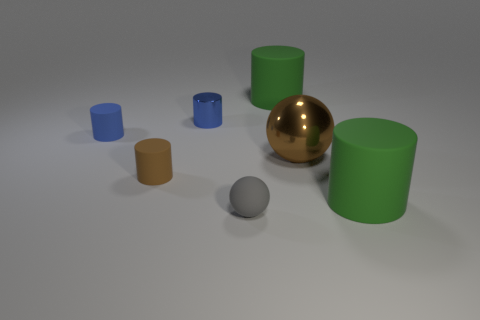Do the rubber sphere and the brown metal sphere have the same size?
Offer a terse response. No. There is a blue object that is the same material as the small gray ball; what shape is it?
Ensure brevity in your answer.  Cylinder. What number of other objects are there of the same shape as the gray matte object?
Keep it short and to the point. 1. The brown object behind the tiny rubber cylinder that is in front of the metal thing that is to the right of the matte ball is what shape?
Give a very brief answer. Sphere. What number of spheres are either tiny gray matte things or brown things?
Make the answer very short. 2. Is there a green object in front of the brown object that is on the right side of the gray matte ball?
Your answer should be compact. Yes. Are there any other things that are the same material as the large brown sphere?
Provide a short and direct response. Yes. There is a gray object; is its shape the same as the large green rubber object in front of the brown shiny sphere?
Provide a succinct answer. No. What number of other objects are there of the same size as the brown rubber cylinder?
Provide a succinct answer. 3. How many brown objects are large spheres or tiny shiny objects?
Ensure brevity in your answer.  1. 